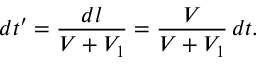<formula> <loc_0><loc_0><loc_500><loc_500>d t ^ { \prime } = \frac { d l } { V + V _ { 1 } } = \frac { V } { V + V _ { 1 } } \, d t .</formula> 